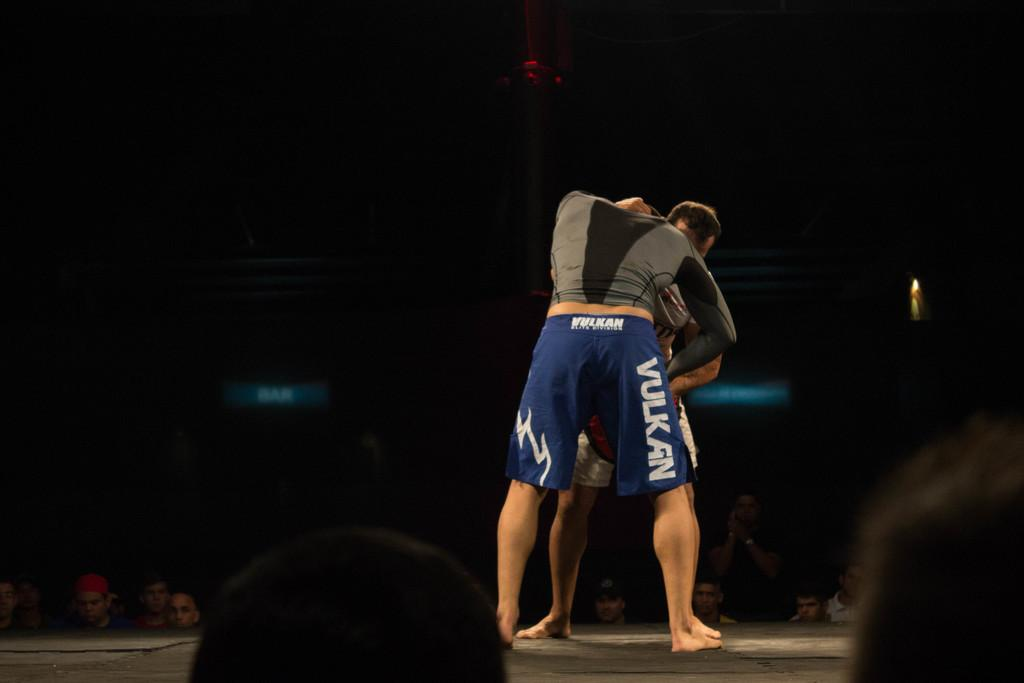<image>
Share a concise interpretation of the image provided. Man wearing blue shorts which says VULKAN fighting someone. 